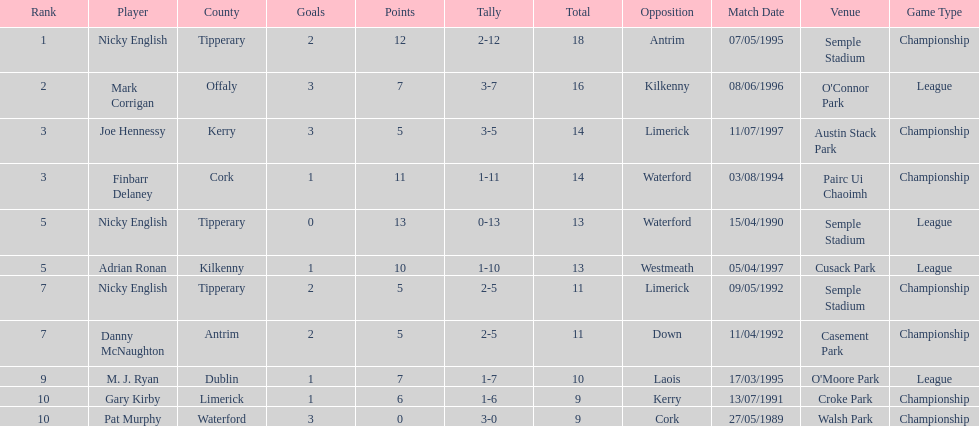What is the least total on the list? 9. 